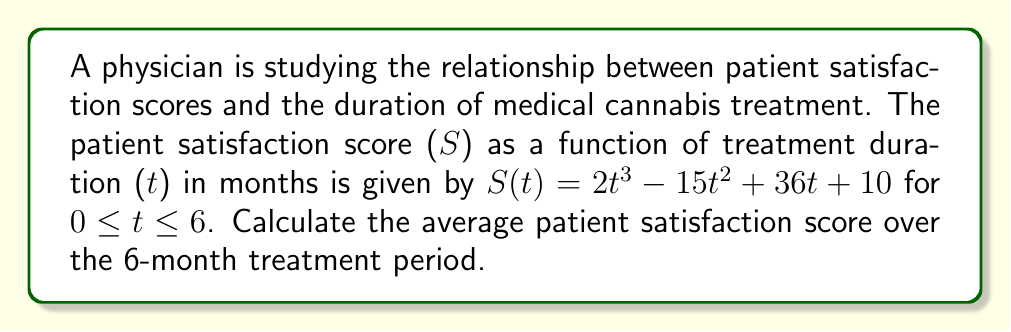Solve this math problem. To find the average patient satisfaction score over the 6-month period, we need to:

1. Compute the integral of S(t) from 0 to 6 months.
2. Divide the result by the length of the interval (6 months).

Step 1: Integrate S(t) from 0 to 6

$$\int_0^6 S(t) dt = \int_0^6 (2t^3 - 15t^2 + 36t + 10) dt$$

Integrate each term:
$$\begin{align*}
&= \left[\frac{1}{2}t^4 - 5t^3 + 18t^2 + 10t\right]_0^6 \\
&= \left(\frac{1}{2}(6^4) - 5(6^3) + 18(6^2) + 10(6)\right) - \left(\frac{1}{2}(0^4) - 5(0^3) + 18(0^2) + 10(0)\right) \\
&= (648 - 1080 + 648 + 60) - 0 \\
&= 276
\end{align*}$$

Step 2: Divide by the interval length

Average satisfaction = $\frac{276}{6} = 46$

Therefore, the average patient satisfaction score over the 6-month treatment period is 46.
Answer: 46 